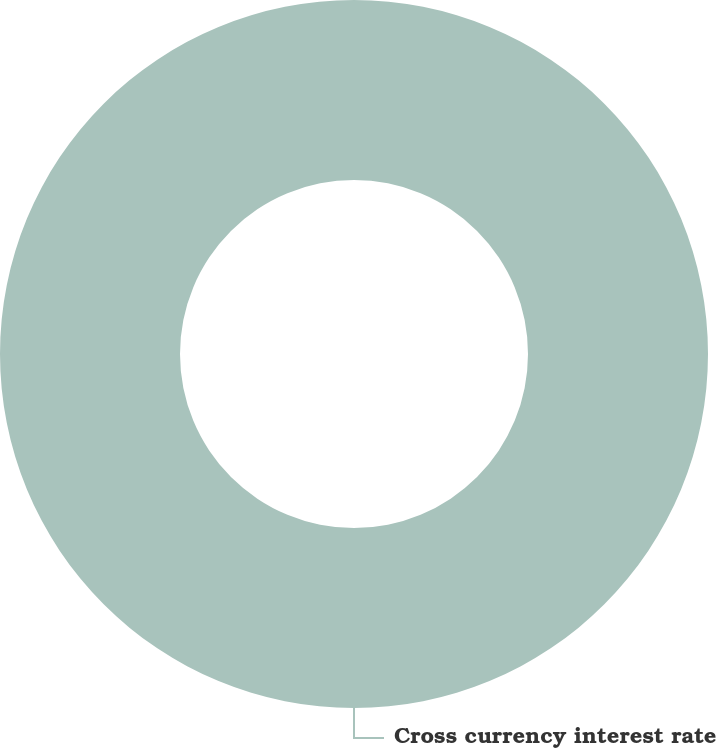Convert chart. <chart><loc_0><loc_0><loc_500><loc_500><pie_chart><fcel>Cross currency interest rate<nl><fcel>100.0%<nl></chart> 